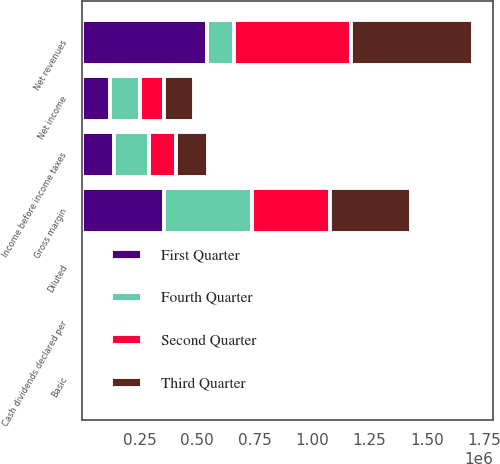Convert chart. <chart><loc_0><loc_0><loc_500><loc_500><stacked_bar_chart><ecel><fcel>Net revenues<fcel>Gross margin<fcel>Income before income taxes<fcel>Net income<fcel>Basic<fcel>Diluted<fcel>Cash dividends declared per<nl><fcel>Fourth Quarter<fcel>115693<fcel>384373<fcel>154905<fcel>129831<fcel>0.49<fcel>0.47<fcel>0.22<nl><fcel>First Quarter<fcel>543933<fcel>356220<fcel>138083<fcel>123437<fcel>0.47<fcel>0.46<fcel>0.22<nl><fcel>Second Quarter<fcel>509767<fcel>339274<fcel>115693<fcel>103648<fcel>0.4<fcel>0.38<fcel>0.22<nl><fcel>Third Quarter<fcel>532168<fcel>351579<fcel>138325<fcel>130620<fcel>0.5<fcel>0.47<fcel>0.22<nl></chart> 